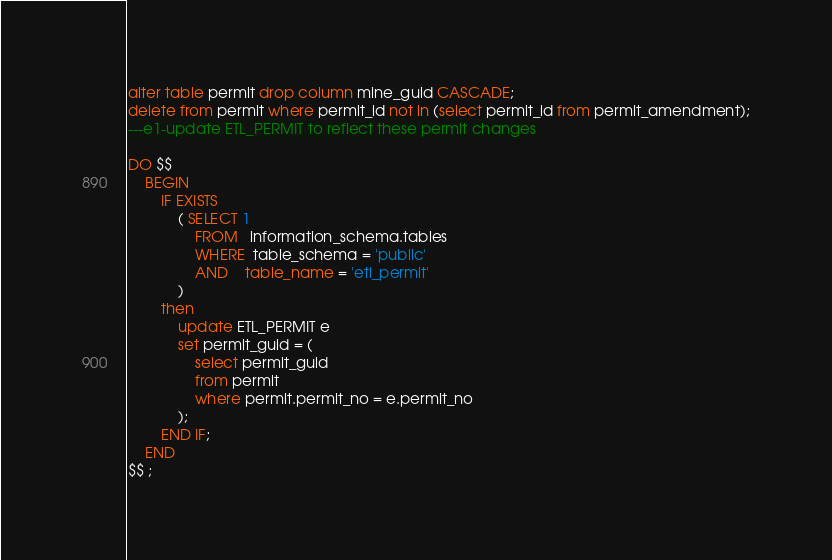Convert code to text. <code><loc_0><loc_0><loc_500><loc_500><_SQL_>alter table permit drop column mine_guid CASCADE;
delete from permit where permit_id not in (select permit_id from permit_amendment);
---e1-update ETL_PERMIT to reflect these permit changes

DO $$   
    BEGIN 
        IF EXISTS
            ( SELECT 1
                FROM   information_schema.tables 
                WHERE  table_schema = 'public'
                AND    table_name = 'etl_permit'
            )
        then
            update ETL_PERMIT e
            set permit_guid = (
                select permit_guid 
                from permit 
                where permit.permit_no = e.permit_no
            );
        END IF;
    END
$$ ;</code> 